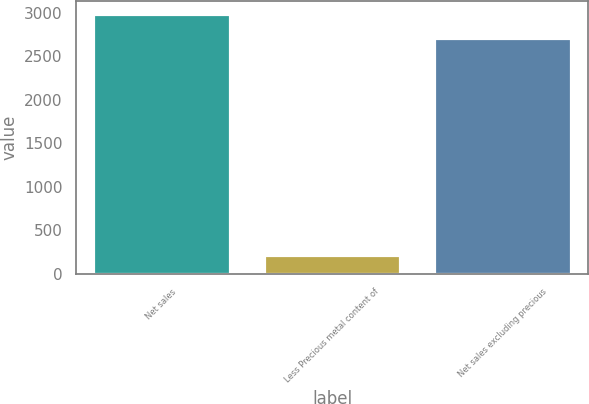Convert chart to OTSL. <chart><loc_0><loc_0><loc_500><loc_500><bar_chart><fcel>Net sales<fcel>Less Precious metal content of<fcel>Net sales excluding precious<nl><fcel>2986.17<fcel>213.7<fcel>2714.7<nl></chart> 